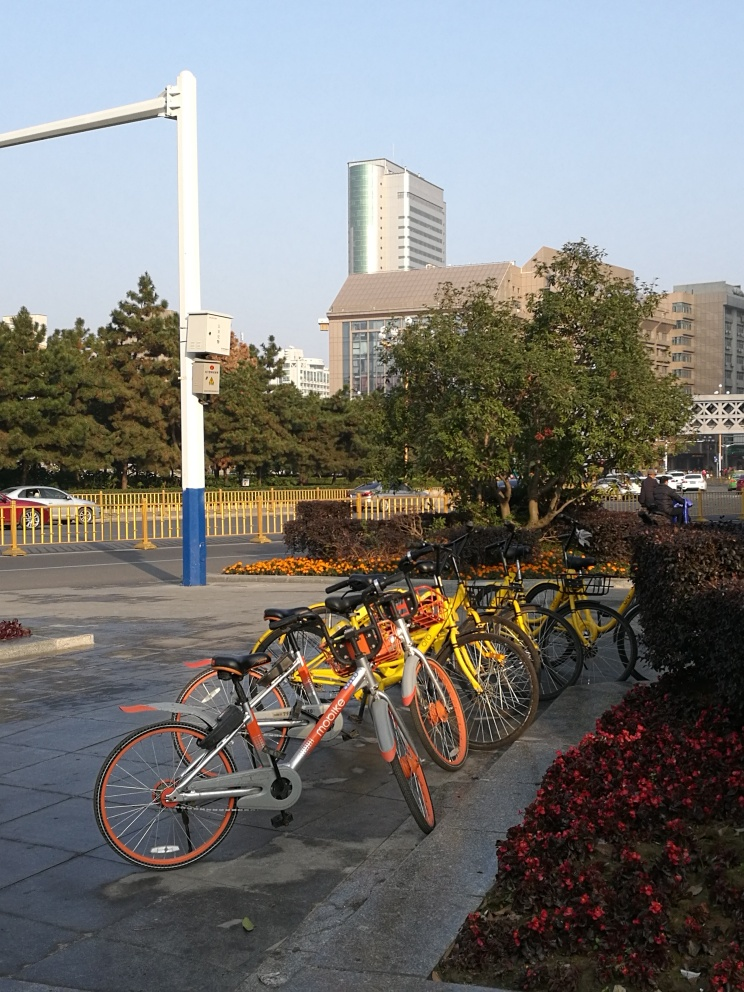Is there any chromatic aberration in the photo?
 No 